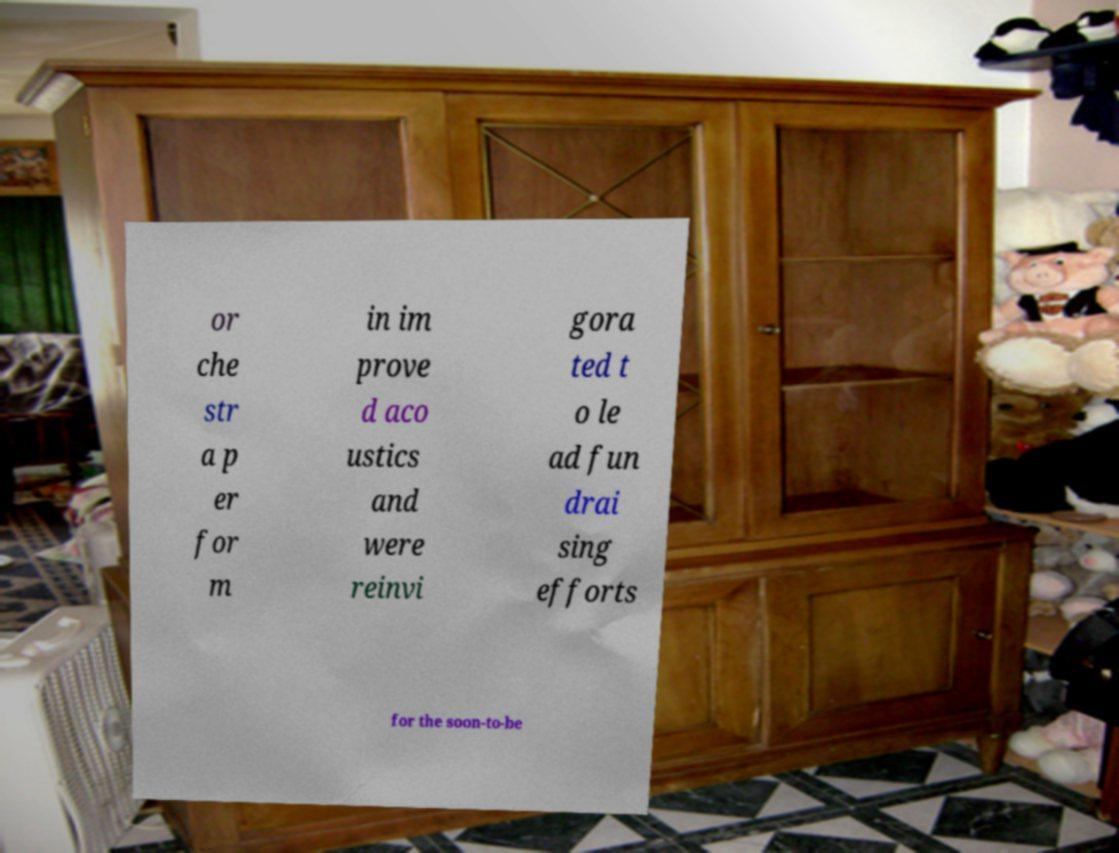Please read and relay the text visible in this image. What does it say? or che str a p er for m in im prove d aco ustics and were reinvi gora ted t o le ad fun drai sing efforts for the soon-to-be 